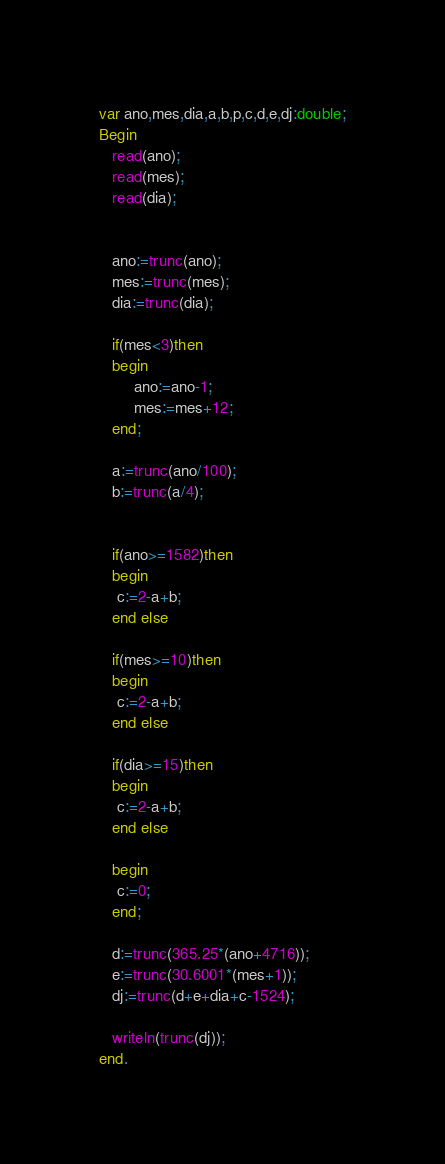<code> <loc_0><loc_0><loc_500><loc_500><_Pascal_>var ano,mes,dia,a,b,p,c,d,e,dj:double;
Begin
   read(ano);
   read(mes);
   read(dia);


   ano:=trunc(ano);
   mes:=trunc(mes);
   dia:=trunc(dia);

   if(mes<3)then
   begin
        ano:=ano-1;
        mes:=mes+12;
   end;

   a:=trunc(ano/100);
   b:=trunc(a/4);


   if(ano>=1582)then
   begin
    c:=2-a+b;
   end else

   if(mes>=10)then
   begin
    c:=2-a+b;
   end else

   if(dia>=15)then
   begin
    c:=2-a+b;
   end else

   begin
    c:=0;
   end;

   d:=trunc(365.25*(ano+4716));
   e:=trunc(30.6001*(mes+1));
   dj:=trunc(d+e+dia+c-1524);

   writeln(trunc(dj));
end.
</code> 